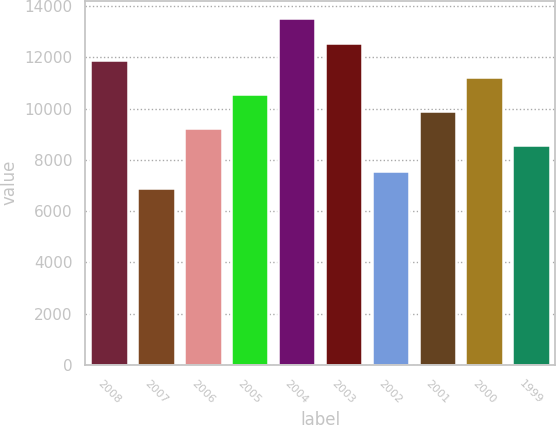Convert chart. <chart><loc_0><loc_0><loc_500><loc_500><bar_chart><fcel>2008<fcel>2007<fcel>2006<fcel>2005<fcel>2004<fcel>2003<fcel>2002<fcel>2001<fcel>2000<fcel>1999<nl><fcel>11897.5<fcel>6890<fcel>9237.9<fcel>10567.7<fcel>13539<fcel>12562.4<fcel>7554.9<fcel>9902.8<fcel>11232.6<fcel>8573<nl></chart> 